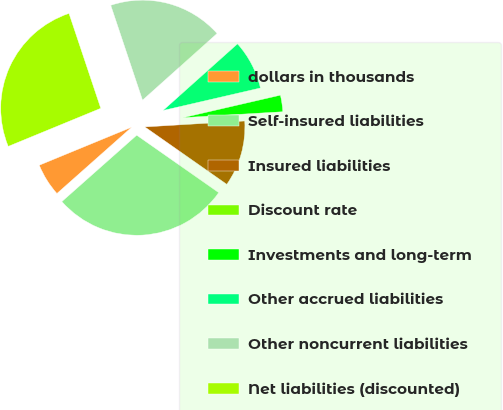<chart> <loc_0><loc_0><loc_500><loc_500><pie_chart><fcel>dollars in thousands<fcel>Self-insured liabilities<fcel>Insured liabilities<fcel>Discount rate<fcel>Investments and long-term<fcel>Other accrued liabilities<fcel>Other noncurrent liabilities<fcel>Net liabilities (discounted)<nl><fcel>5.33%<fcel>28.73%<fcel>10.67%<fcel>0.0%<fcel>2.67%<fcel>8.0%<fcel>18.53%<fcel>26.07%<nl></chart> 